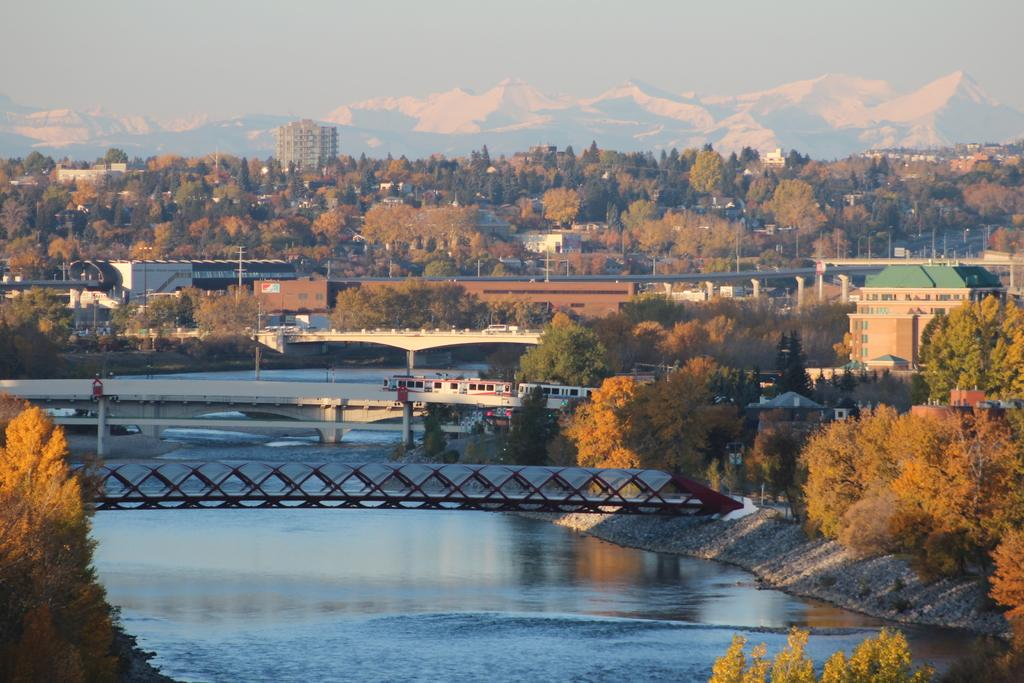What type of structures can be seen in the image? There are bridges, buildings, and poles in the image. What type of natural elements are present in the image? There are trees, mountains, and water at the bottom of the image. What type of transportation can be seen in the image? There are vehicles on the road in the image. What other objects can be seen in the image? There are boards in the image. What is visible at the top of the image? There is sky at the top of the image. Can you tell me how many grapes are hanging from the trees in the image? There are no grapes present in the image; it features trees without any fruit. What type of cattle can be seen grazing near the water in the image? There is no cattle present in the image; it features vehicles on the road and no animals are visible. 